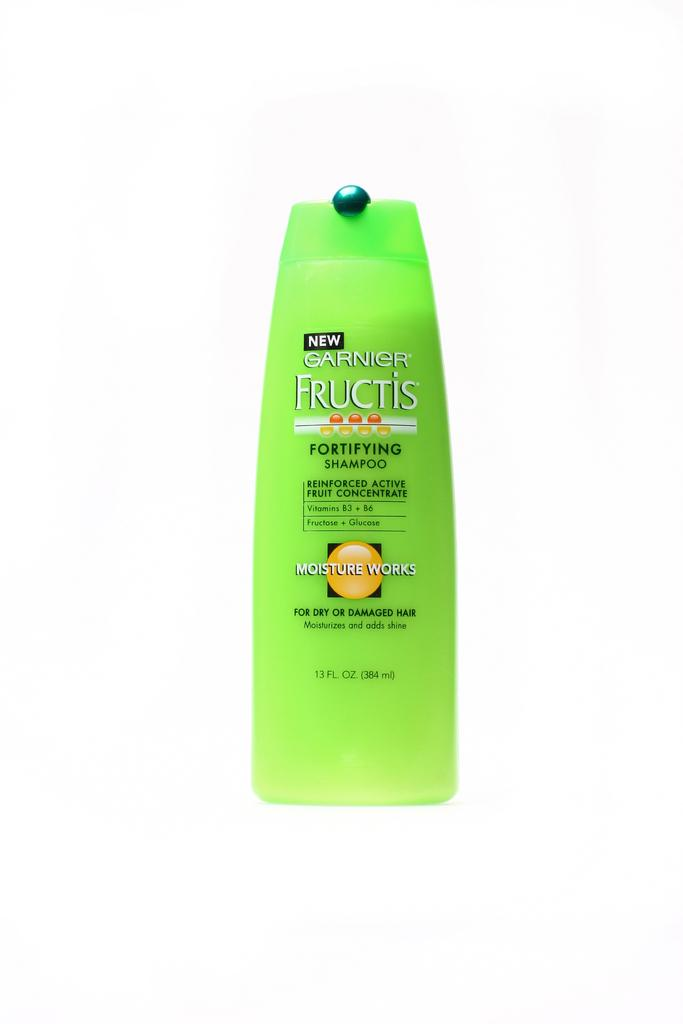<image>
Share a concise interpretation of the image provided. A green plastic bottle of Garnier brand Fructis shampoo. 